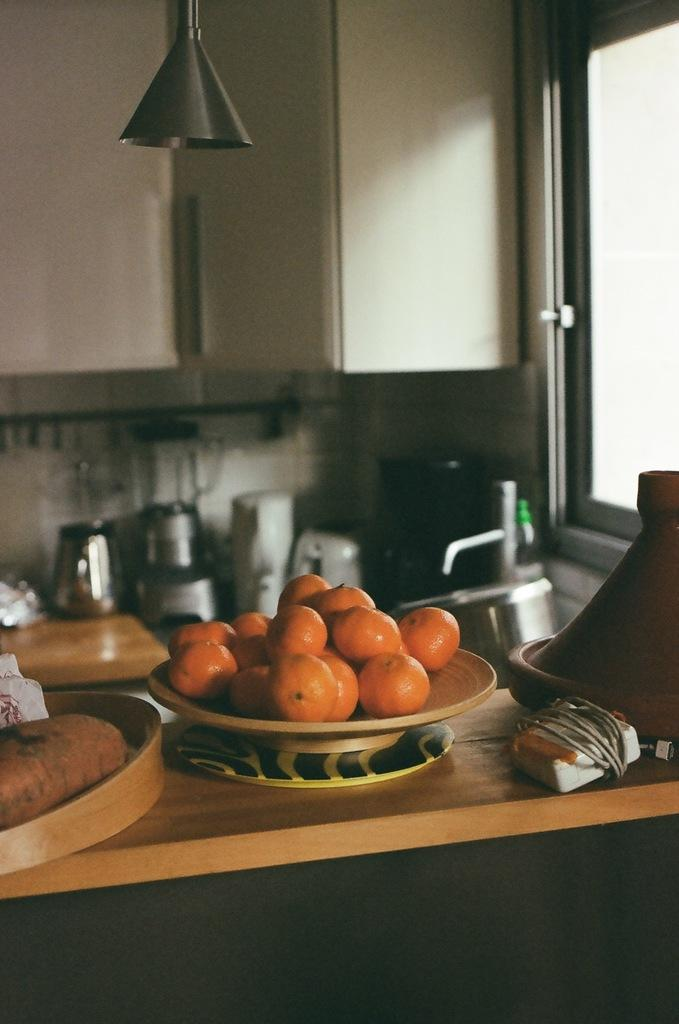What is on the table in the image? There is a bowl, a plate, a tray, fruits, and unspecified things on the table. What type of furniture is the table in the image? The table is a piece of furniture. Is there any water source visible in the image? Yes, there is a sink with a tap visible in the image. What is the purpose of the cable in the image? The purpose of the cable is not specified in the image. What type of destruction is taking place in the image? There is no destruction present in the image. Is there a prison visible in the image? There is no prison present in the image. 